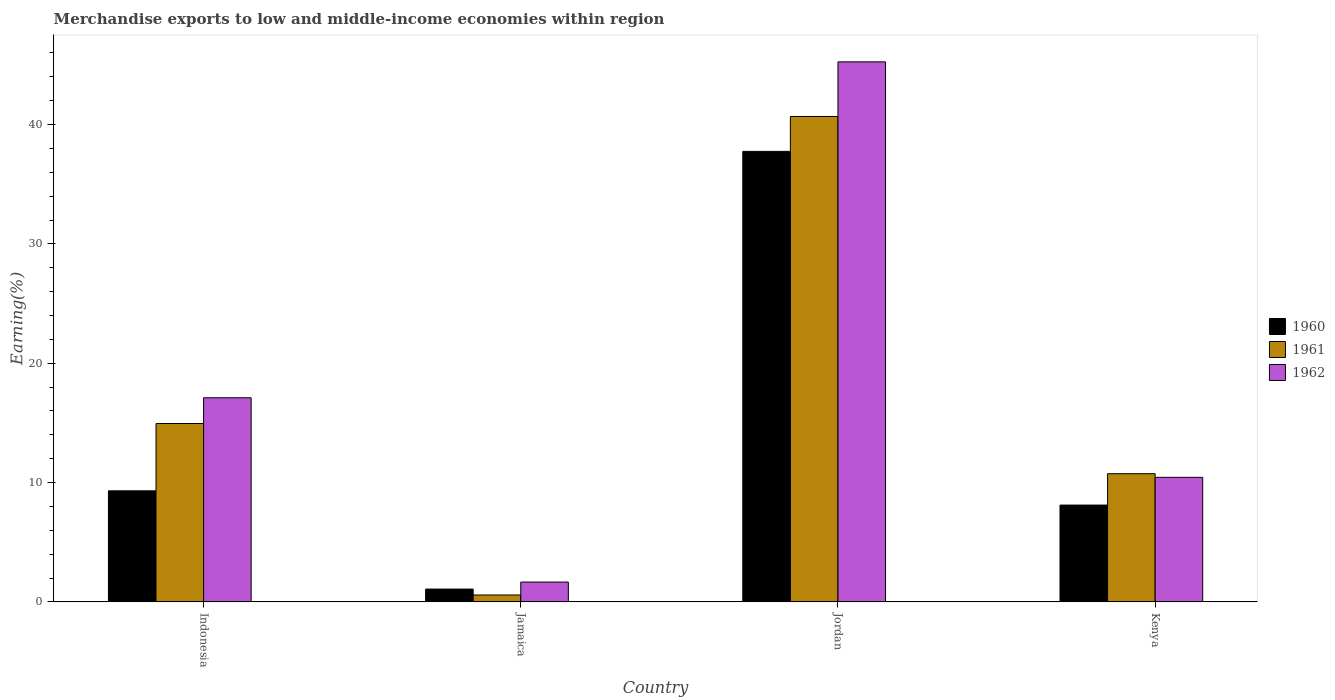How many different coloured bars are there?
Your response must be concise. 3. How many groups of bars are there?
Your answer should be very brief. 4. Are the number of bars per tick equal to the number of legend labels?
Ensure brevity in your answer.  Yes. Are the number of bars on each tick of the X-axis equal?
Provide a succinct answer. Yes. What is the label of the 1st group of bars from the left?
Your answer should be very brief. Indonesia. What is the percentage of amount earned from merchandise exports in 1962 in Indonesia?
Provide a short and direct response. 17.11. Across all countries, what is the maximum percentage of amount earned from merchandise exports in 1960?
Make the answer very short. 37.76. Across all countries, what is the minimum percentage of amount earned from merchandise exports in 1962?
Provide a short and direct response. 1.66. In which country was the percentage of amount earned from merchandise exports in 1960 maximum?
Your answer should be very brief. Jordan. In which country was the percentage of amount earned from merchandise exports in 1962 minimum?
Provide a succinct answer. Jamaica. What is the total percentage of amount earned from merchandise exports in 1960 in the graph?
Keep it short and to the point. 56.25. What is the difference between the percentage of amount earned from merchandise exports in 1961 in Indonesia and that in Kenya?
Offer a very short reply. 4.21. What is the difference between the percentage of amount earned from merchandise exports in 1960 in Jordan and the percentage of amount earned from merchandise exports in 1962 in Indonesia?
Ensure brevity in your answer.  20.65. What is the average percentage of amount earned from merchandise exports in 1960 per country?
Ensure brevity in your answer.  14.06. What is the difference between the percentage of amount earned from merchandise exports of/in 1962 and percentage of amount earned from merchandise exports of/in 1961 in Jamaica?
Make the answer very short. 1.08. In how many countries, is the percentage of amount earned from merchandise exports in 1962 greater than 30 %?
Provide a succinct answer. 1. What is the ratio of the percentage of amount earned from merchandise exports in 1961 in Jamaica to that in Kenya?
Your answer should be very brief. 0.05. Is the difference between the percentage of amount earned from merchandise exports in 1962 in Jordan and Kenya greater than the difference between the percentage of amount earned from merchandise exports in 1961 in Jordan and Kenya?
Your answer should be very brief. Yes. What is the difference between the highest and the second highest percentage of amount earned from merchandise exports in 1961?
Make the answer very short. 29.94. What is the difference between the highest and the lowest percentage of amount earned from merchandise exports in 1961?
Provide a short and direct response. 40.1. What does the 3rd bar from the left in Jamaica represents?
Make the answer very short. 1962. How many bars are there?
Your response must be concise. 12. Does the graph contain grids?
Ensure brevity in your answer.  No. Where does the legend appear in the graph?
Ensure brevity in your answer.  Center right. How many legend labels are there?
Give a very brief answer. 3. What is the title of the graph?
Your answer should be compact. Merchandise exports to low and middle-income economies within region. What is the label or title of the X-axis?
Provide a short and direct response. Country. What is the label or title of the Y-axis?
Provide a short and direct response. Earning(%). What is the Earning(%) in 1960 in Indonesia?
Provide a short and direct response. 9.31. What is the Earning(%) of 1961 in Indonesia?
Ensure brevity in your answer.  14.95. What is the Earning(%) of 1962 in Indonesia?
Your answer should be very brief. 17.11. What is the Earning(%) in 1960 in Jamaica?
Give a very brief answer. 1.07. What is the Earning(%) of 1961 in Jamaica?
Provide a short and direct response. 0.58. What is the Earning(%) in 1962 in Jamaica?
Your response must be concise. 1.66. What is the Earning(%) in 1960 in Jordan?
Your answer should be very brief. 37.76. What is the Earning(%) in 1961 in Jordan?
Offer a terse response. 40.68. What is the Earning(%) of 1962 in Jordan?
Give a very brief answer. 45.26. What is the Earning(%) of 1960 in Kenya?
Offer a terse response. 8.11. What is the Earning(%) in 1961 in Kenya?
Ensure brevity in your answer.  10.74. What is the Earning(%) in 1962 in Kenya?
Your answer should be very brief. 10.44. Across all countries, what is the maximum Earning(%) of 1960?
Your answer should be compact. 37.76. Across all countries, what is the maximum Earning(%) of 1961?
Your answer should be very brief. 40.68. Across all countries, what is the maximum Earning(%) of 1962?
Keep it short and to the point. 45.26. Across all countries, what is the minimum Earning(%) in 1960?
Make the answer very short. 1.07. Across all countries, what is the minimum Earning(%) in 1961?
Offer a terse response. 0.58. Across all countries, what is the minimum Earning(%) of 1962?
Ensure brevity in your answer.  1.66. What is the total Earning(%) in 1960 in the graph?
Your response must be concise. 56.25. What is the total Earning(%) in 1961 in the graph?
Your answer should be compact. 66.95. What is the total Earning(%) in 1962 in the graph?
Make the answer very short. 74.46. What is the difference between the Earning(%) in 1960 in Indonesia and that in Jamaica?
Give a very brief answer. 8.23. What is the difference between the Earning(%) in 1961 in Indonesia and that in Jamaica?
Your answer should be very brief. 14.37. What is the difference between the Earning(%) of 1962 in Indonesia and that in Jamaica?
Your answer should be very brief. 15.45. What is the difference between the Earning(%) in 1960 in Indonesia and that in Jordan?
Your answer should be compact. -28.45. What is the difference between the Earning(%) of 1961 in Indonesia and that in Jordan?
Your response must be concise. -25.73. What is the difference between the Earning(%) in 1962 in Indonesia and that in Jordan?
Your answer should be compact. -28.15. What is the difference between the Earning(%) of 1960 in Indonesia and that in Kenya?
Keep it short and to the point. 1.19. What is the difference between the Earning(%) in 1961 in Indonesia and that in Kenya?
Ensure brevity in your answer.  4.21. What is the difference between the Earning(%) of 1962 in Indonesia and that in Kenya?
Your response must be concise. 6.67. What is the difference between the Earning(%) of 1960 in Jamaica and that in Jordan?
Give a very brief answer. -36.68. What is the difference between the Earning(%) of 1961 in Jamaica and that in Jordan?
Your response must be concise. -40.1. What is the difference between the Earning(%) in 1962 in Jamaica and that in Jordan?
Your answer should be very brief. -43.6. What is the difference between the Earning(%) of 1960 in Jamaica and that in Kenya?
Keep it short and to the point. -7.04. What is the difference between the Earning(%) in 1961 in Jamaica and that in Kenya?
Your answer should be very brief. -10.17. What is the difference between the Earning(%) of 1962 in Jamaica and that in Kenya?
Give a very brief answer. -8.78. What is the difference between the Earning(%) of 1960 in Jordan and that in Kenya?
Your answer should be compact. 29.64. What is the difference between the Earning(%) of 1961 in Jordan and that in Kenya?
Your answer should be compact. 29.94. What is the difference between the Earning(%) in 1962 in Jordan and that in Kenya?
Offer a terse response. 34.82. What is the difference between the Earning(%) in 1960 in Indonesia and the Earning(%) in 1961 in Jamaica?
Provide a succinct answer. 8.73. What is the difference between the Earning(%) in 1960 in Indonesia and the Earning(%) in 1962 in Jamaica?
Offer a terse response. 7.65. What is the difference between the Earning(%) in 1961 in Indonesia and the Earning(%) in 1962 in Jamaica?
Make the answer very short. 13.29. What is the difference between the Earning(%) in 1960 in Indonesia and the Earning(%) in 1961 in Jordan?
Your response must be concise. -31.37. What is the difference between the Earning(%) of 1960 in Indonesia and the Earning(%) of 1962 in Jordan?
Provide a short and direct response. -35.95. What is the difference between the Earning(%) in 1961 in Indonesia and the Earning(%) in 1962 in Jordan?
Ensure brevity in your answer.  -30.31. What is the difference between the Earning(%) in 1960 in Indonesia and the Earning(%) in 1961 in Kenya?
Ensure brevity in your answer.  -1.44. What is the difference between the Earning(%) of 1960 in Indonesia and the Earning(%) of 1962 in Kenya?
Offer a very short reply. -1.13. What is the difference between the Earning(%) of 1961 in Indonesia and the Earning(%) of 1962 in Kenya?
Keep it short and to the point. 4.51. What is the difference between the Earning(%) in 1960 in Jamaica and the Earning(%) in 1961 in Jordan?
Your answer should be very brief. -39.6. What is the difference between the Earning(%) of 1960 in Jamaica and the Earning(%) of 1962 in Jordan?
Provide a succinct answer. -44.18. What is the difference between the Earning(%) of 1961 in Jamaica and the Earning(%) of 1962 in Jordan?
Your answer should be very brief. -44.68. What is the difference between the Earning(%) in 1960 in Jamaica and the Earning(%) in 1961 in Kenya?
Your answer should be very brief. -9.67. What is the difference between the Earning(%) in 1960 in Jamaica and the Earning(%) in 1962 in Kenya?
Ensure brevity in your answer.  -9.36. What is the difference between the Earning(%) of 1961 in Jamaica and the Earning(%) of 1962 in Kenya?
Your response must be concise. -9.86. What is the difference between the Earning(%) of 1960 in Jordan and the Earning(%) of 1961 in Kenya?
Make the answer very short. 27.01. What is the difference between the Earning(%) of 1960 in Jordan and the Earning(%) of 1962 in Kenya?
Give a very brief answer. 27.32. What is the difference between the Earning(%) of 1961 in Jordan and the Earning(%) of 1962 in Kenya?
Provide a succinct answer. 30.24. What is the average Earning(%) of 1960 per country?
Offer a terse response. 14.06. What is the average Earning(%) of 1961 per country?
Offer a very short reply. 16.74. What is the average Earning(%) in 1962 per country?
Offer a terse response. 18.61. What is the difference between the Earning(%) in 1960 and Earning(%) in 1961 in Indonesia?
Provide a succinct answer. -5.64. What is the difference between the Earning(%) of 1960 and Earning(%) of 1962 in Indonesia?
Offer a very short reply. -7.8. What is the difference between the Earning(%) of 1961 and Earning(%) of 1962 in Indonesia?
Make the answer very short. -2.16. What is the difference between the Earning(%) in 1960 and Earning(%) in 1961 in Jamaica?
Provide a short and direct response. 0.5. What is the difference between the Earning(%) of 1960 and Earning(%) of 1962 in Jamaica?
Your response must be concise. -0.59. What is the difference between the Earning(%) of 1961 and Earning(%) of 1962 in Jamaica?
Ensure brevity in your answer.  -1.08. What is the difference between the Earning(%) in 1960 and Earning(%) in 1961 in Jordan?
Keep it short and to the point. -2.92. What is the difference between the Earning(%) of 1960 and Earning(%) of 1962 in Jordan?
Make the answer very short. -7.5. What is the difference between the Earning(%) in 1961 and Earning(%) in 1962 in Jordan?
Provide a succinct answer. -4.58. What is the difference between the Earning(%) in 1960 and Earning(%) in 1961 in Kenya?
Provide a succinct answer. -2.63. What is the difference between the Earning(%) of 1960 and Earning(%) of 1962 in Kenya?
Your response must be concise. -2.32. What is the difference between the Earning(%) of 1961 and Earning(%) of 1962 in Kenya?
Offer a terse response. 0.31. What is the ratio of the Earning(%) in 1960 in Indonesia to that in Jamaica?
Your answer should be compact. 8.67. What is the ratio of the Earning(%) in 1961 in Indonesia to that in Jamaica?
Offer a very short reply. 25.91. What is the ratio of the Earning(%) of 1962 in Indonesia to that in Jamaica?
Ensure brevity in your answer.  10.3. What is the ratio of the Earning(%) in 1960 in Indonesia to that in Jordan?
Keep it short and to the point. 0.25. What is the ratio of the Earning(%) of 1961 in Indonesia to that in Jordan?
Give a very brief answer. 0.37. What is the ratio of the Earning(%) in 1962 in Indonesia to that in Jordan?
Offer a very short reply. 0.38. What is the ratio of the Earning(%) in 1960 in Indonesia to that in Kenya?
Your answer should be compact. 1.15. What is the ratio of the Earning(%) in 1961 in Indonesia to that in Kenya?
Keep it short and to the point. 1.39. What is the ratio of the Earning(%) of 1962 in Indonesia to that in Kenya?
Your answer should be compact. 1.64. What is the ratio of the Earning(%) in 1960 in Jamaica to that in Jordan?
Offer a terse response. 0.03. What is the ratio of the Earning(%) of 1961 in Jamaica to that in Jordan?
Provide a succinct answer. 0.01. What is the ratio of the Earning(%) in 1962 in Jamaica to that in Jordan?
Offer a very short reply. 0.04. What is the ratio of the Earning(%) of 1960 in Jamaica to that in Kenya?
Keep it short and to the point. 0.13. What is the ratio of the Earning(%) of 1961 in Jamaica to that in Kenya?
Keep it short and to the point. 0.05. What is the ratio of the Earning(%) of 1962 in Jamaica to that in Kenya?
Provide a succinct answer. 0.16. What is the ratio of the Earning(%) in 1960 in Jordan to that in Kenya?
Give a very brief answer. 4.65. What is the ratio of the Earning(%) in 1961 in Jordan to that in Kenya?
Your response must be concise. 3.79. What is the ratio of the Earning(%) of 1962 in Jordan to that in Kenya?
Your answer should be very brief. 4.34. What is the difference between the highest and the second highest Earning(%) in 1960?
Your answer should be compact. 28.45. What is the difference between the highest and the second highest Earning(%) of 1961?
Ensure brevity in your answer.  25.73. What is the difference between the highest and the second highest Earning(%) of 1962?
Make the answer very short. 28.15. What is the difference between the highest and the lowest Earning(%) of 1960?
Ensure brevity in your answer.  36.68. What is the difference between the highest and the lowest Earning(%) in 1961?
Provide a succinct answer. 40.1. What is the difference between the highest and the lowest Earning(%) of 1962?
Make the answer very short. 43.6. 